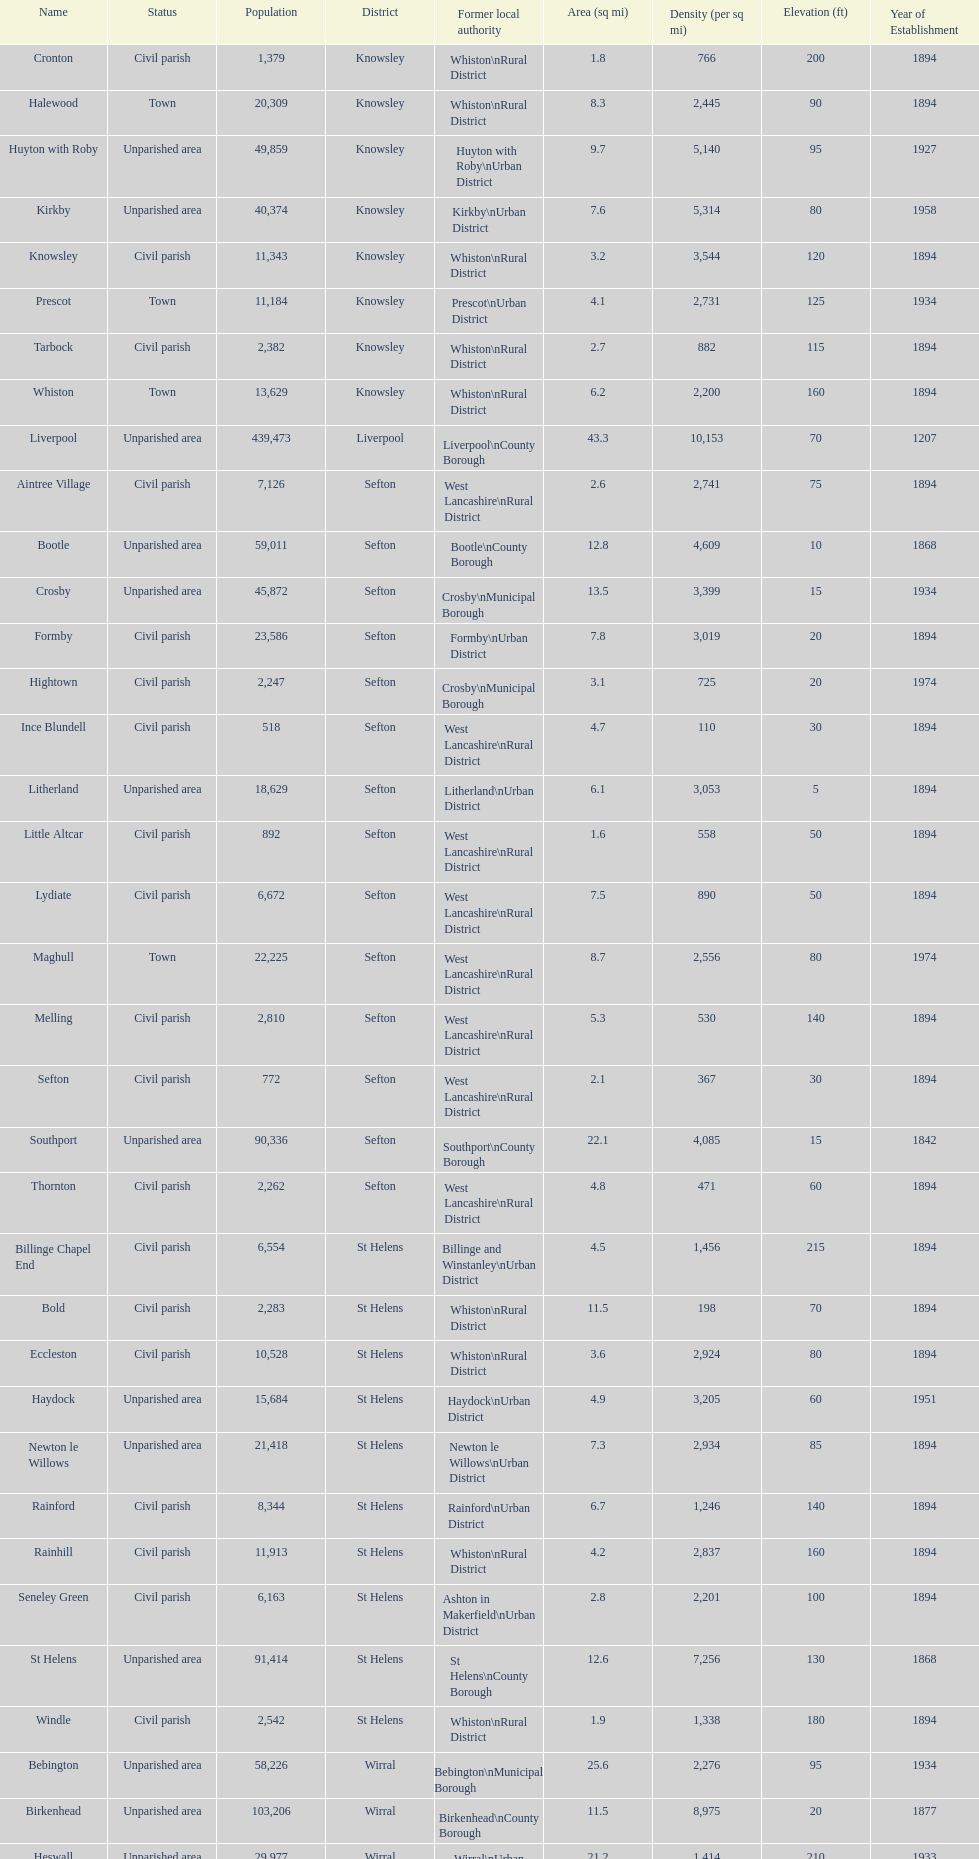Which is a civil parish, aintree village or maghull? Aintree Village. 